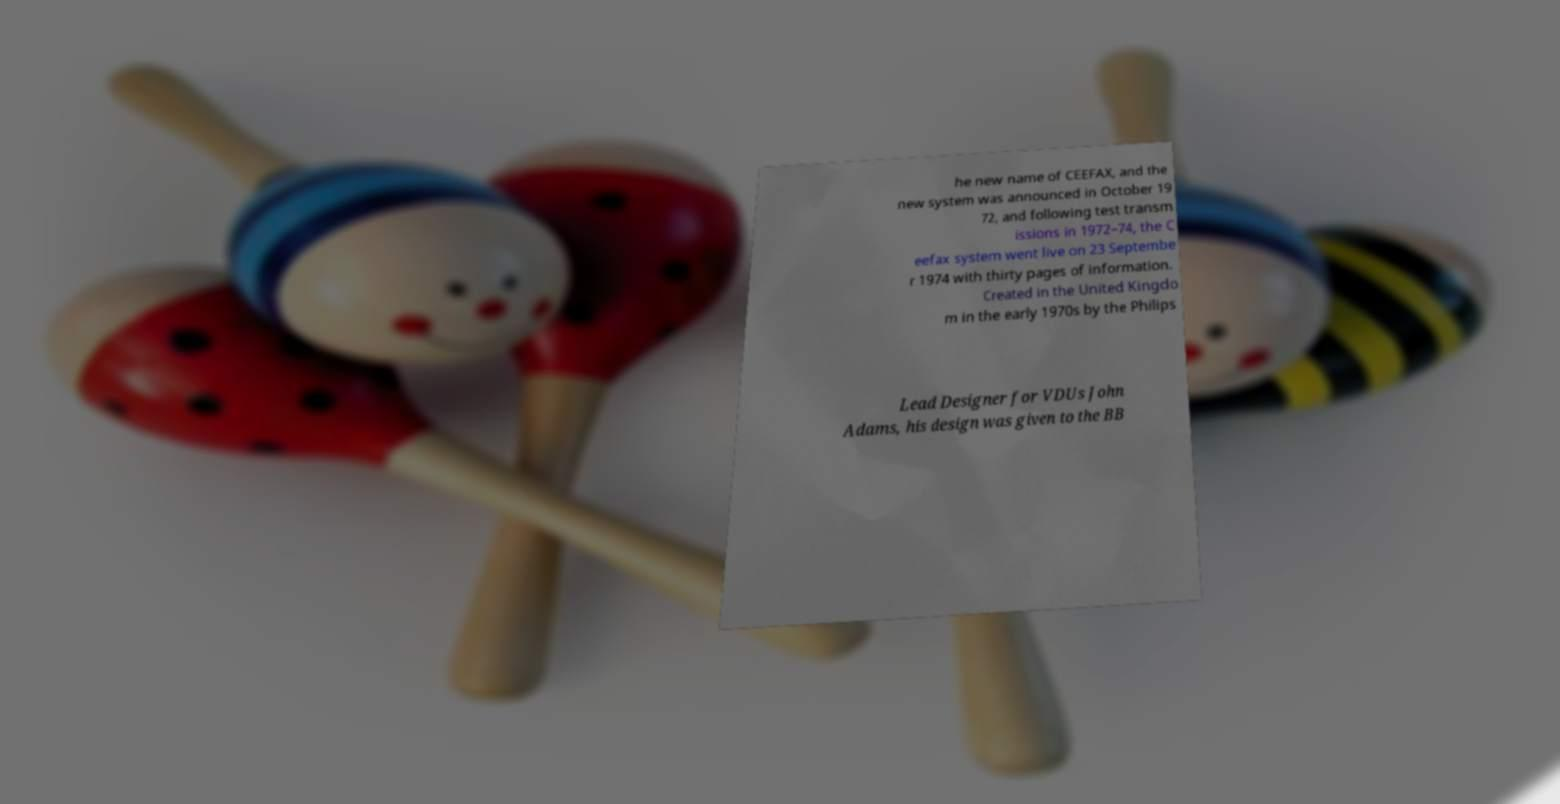I need the written content from this picture converted into text. Can you do that? he new name of CEEFAX, and the new system was announced in October 19 72, and following test transm issions in 1972–74, the C eefax system went live on 23 Septembe r 1974 with thirty pages of information. Created in the United Kingdo m in the early 1970s by the Philips Lead Designer for VDUs John Adams, his design was given to the BB 